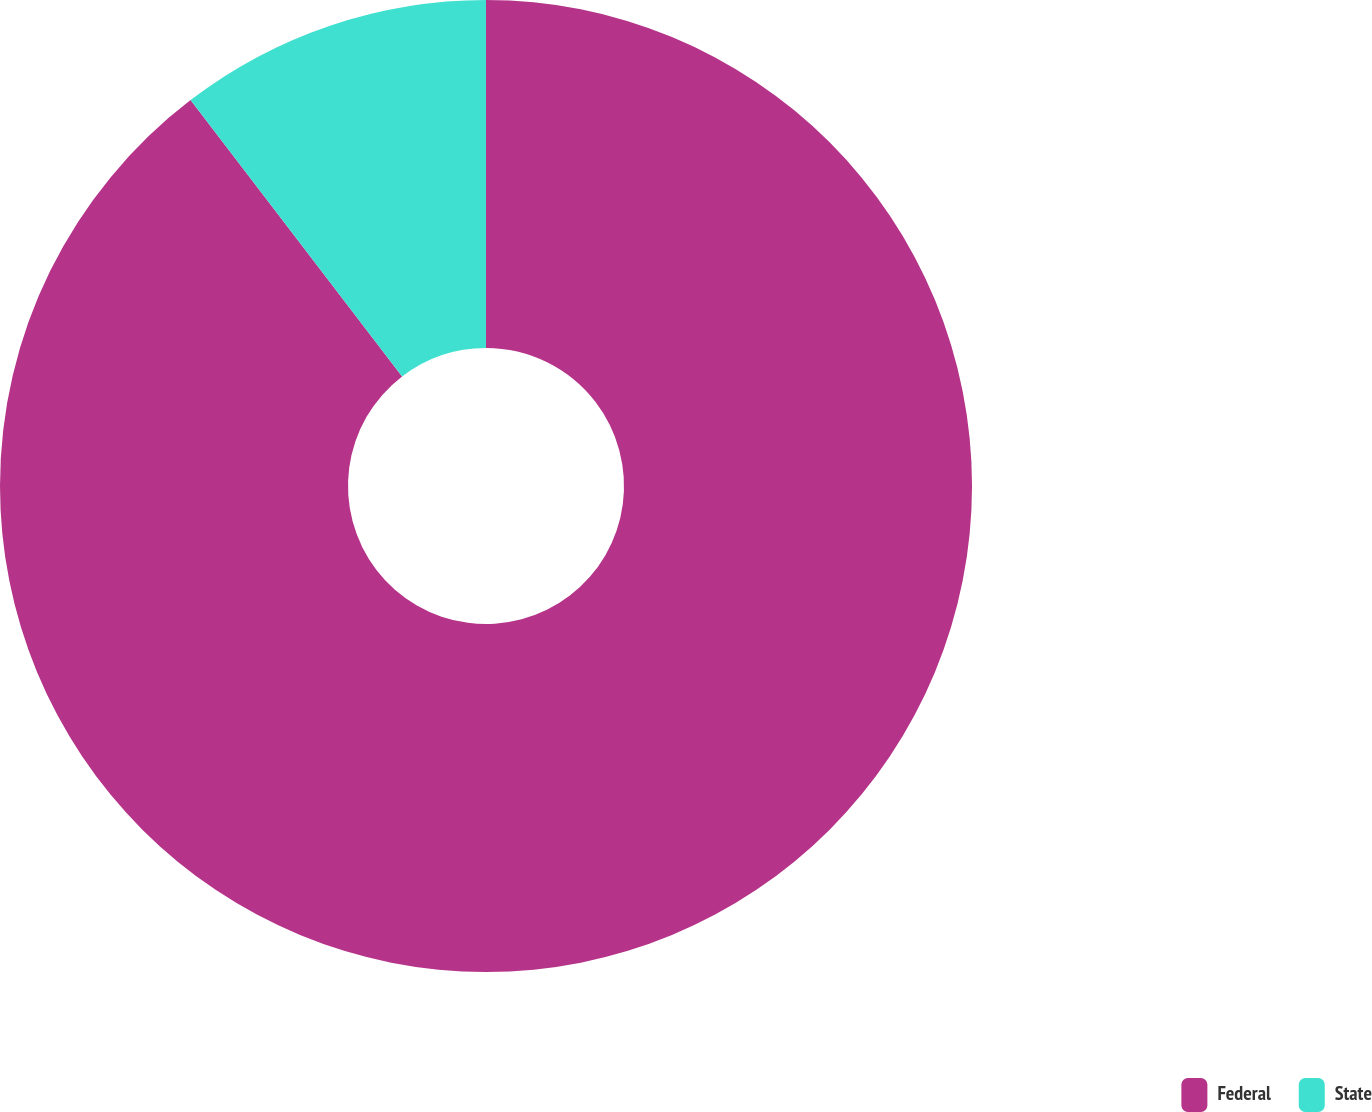<chart> <loc_0><loc_0><loc_500><loc_500><pie_chart><fcel>Federal<fcel>State<nl><fcel>89.6%<fcel>10.4%<nl></chart> 